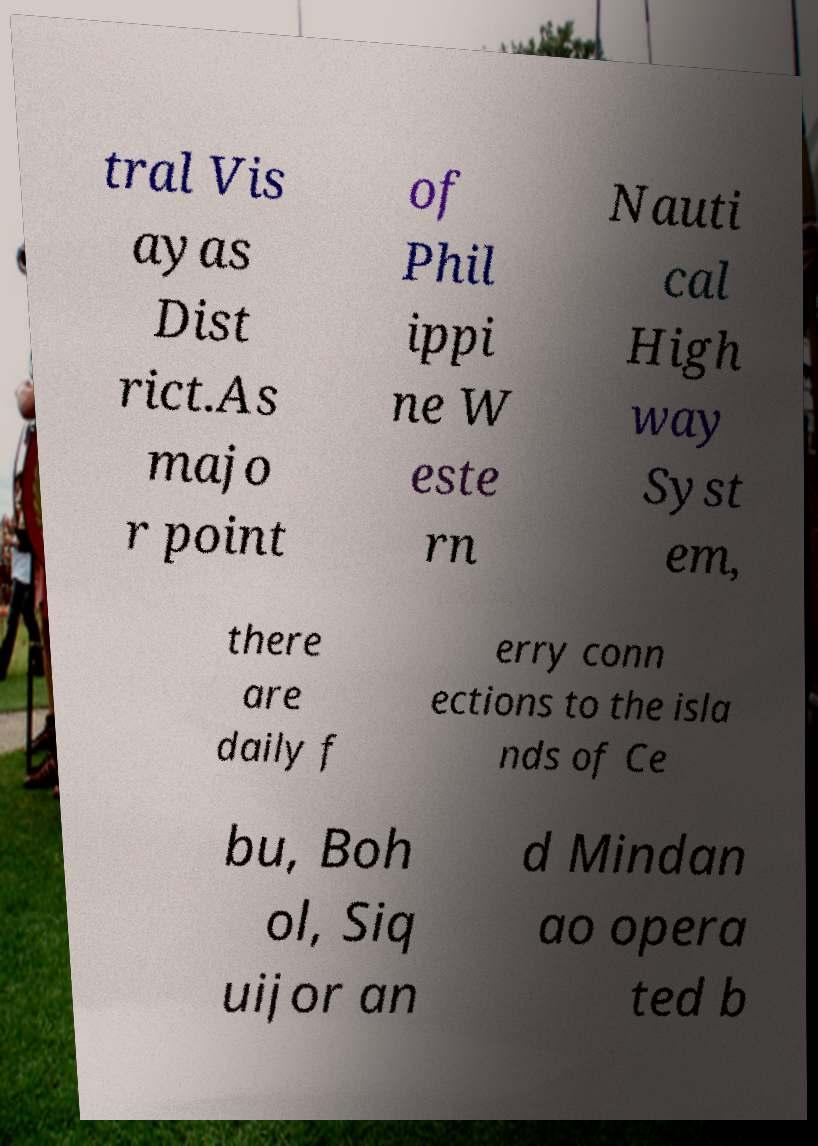For documentation purposes, I need the text within this image transcribed. Could you provide that? tral Vis ayas Dist rict.As majo r point of Phil ippi ne W este rn Nauti cal High way Syst em, there are daily f erry conn ections to the isla nds of Ce bu, Boh ol, Siq uijor an d Mindan ao opera ted b 